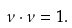<formula> <loc_0><loc_0><loc_500><loc_500>\nu \cdot \nu = 1 .</formula> 